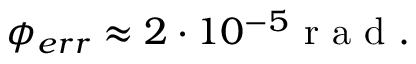Convert formula to latex. <formula><loc_0><loc_0><loc_500><loc_500>\phi _ { e r r } \approx 2 \cdot 1 0 ^ { - 5 } r a d .</formula> 